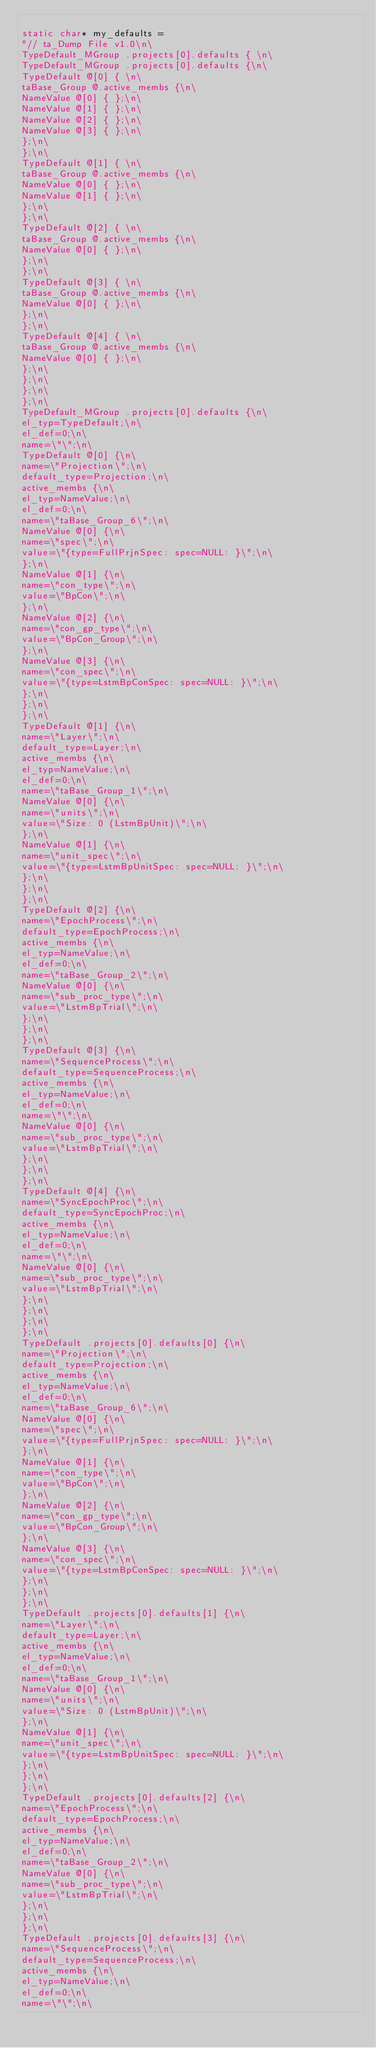<code> <loc_0><loc_0><loc_500><loc_500><_C++_>
static char* my_defaults = 
"// ta_Dump File v1.0\n\
TypeDefault_MGroup .projects[0].defaults { \n\
TypeDefault_MGroup .projects[0].defaults {\n\
TypeDefault @[0] { \n\
taBase_Group @.active_membs {\n\
NameValue @[0] { };\n\
NameValue @[1] { };\n\
NameValue @[2] { };\n\
NameValue @[3] { };\n\
};\n\
};\n\
TypeDefault @[1] { \n\
taBase_Group @.active_membs {\n\
NameValue @[0] { };\n\
NameValue @[1] { };\n\
};\n\
};\n\
TypeDefault @[2] { \n\
taBase_Group @.active_membs {\n\
NameValue @[0] { };\n\
};\n\
};\n\
TypeDefault @[3] { \n\
taBase_Group @.active_membs {\n\
NameValue @[0] { };\n\
};\n\
};\n\
TypeDefault @[4] { \n\
taBase_Group @.active_membs {\n\
NameValue @[0] { };\n\
};\n\
};\n\
};\n\
};\n\
TypeDefault_MGroup .projects[0].defaults {\n\
el_typ=TypeDefault;\n\
el_def=0;\n\
name=\"\";\n\
TypeDefault @[0] {\n\
name=\"Projection\";\n\
default_type=Projection;\n\
active_membs {\n\
el_typ=NameValue;\n\
el_def=0;\n\
name=\"taBase_Group_6\";\n\
NameValue @[0] {\n\
name=\"spec\";\n\
value=\"{type=FullPrjnSpec: spec=NULL: }\";\n\
};\n\
NameValue @[1] {\n\
name=\"con_type\";\n\
value=\"BpCon\";\n\
};\n\
NameValue @[2] {\n\
name=\"con_gp_type\";\n\
value=\"BpCon_Group\";\n\
};\n\
NameValue @[3] {\n\
name=\"con_spec\";\n\
value=\"{type=LstmBpConSpec: spec=NULL: }\";\n\
};\n\
};\n\
};\n\
TypeDefault @[1] {\n\
name=\"Layer\";\n\
default_type=Layer;\n\
active_membs {\n\
el_typ=NameValue;\n\
el_def=0;\n\
name=\"taBase_Group_1\";\n\
NameValue @[0] {\n\
name=\"units\";\n\
value=\"Size: 0 (LstmBpUnit)\";\n\
};\n\
NameValue @[1] {\n\
name=\"unit_spec\";\n\
value=\"{type=LstmBpUnitSpec: spec=NULL: }\";\n\
};\n\
};\n\
};\n\
TypeDefault @[2] {\n\
name=\"EpochProcess\";\n\
default_type=EpochProcess;\n\
active_membs {\n\
el_typ=NameValue;\n\
el_def=0;\n\
name=\"taBase_Group_2\";\n\
NameValue @[0] {\n\
name=\"sub_proc_type\";\n\
value=\"LstmBpTrial\";\n\
};\n\
};\n\
};\n\
TypeDefault @[3] {\n\
name=\"SequenceProcess\";\n\
default_type=SequenceProcess;\n\
active_membs {\n\
el_typ=NameValue;\n\
el_def=0;\n\
name=\"\";\n\
NameValue @[0] {\n\
name=\"sub_proc_type\";\n\
value=\"LstmBpTrial\";\n\
};\n\
};\n\
};\n\
TypeDefault @[4] {\n\
name=\"SyncEpochProc\";\n\
default_type=SyncEpochProc;\n\
active_membs {\n\
el_typ=NameValue;\n\
el_def=0;\n\
name=\"\";\n\
NameValue @[0] {\n\
name=\"sub_proc_type\";\n\
value=\"LstmBpTrial\";\n\
};\n\
};\n\
};\n\
};\n\
TypeDefault .projects[0].defaults[0] {\n\
name=\"Projection\";\n\
default_type=Projection;\n\
active_membs {\n\
el_typ=NameValue;\n\
el_def=0;\n\
name=\"taBase_Group_6\";\n\
NameValue @[0] {\n\
name=\"spec\";\n\
value=\"{type=FullPrjnSpec: spec=NULL: }\";\n\
};\n\
NameValue @[1] {\n\
name=\"con_type\";\n\
value=\"BpCon\";\n\
};\n\
NameValue @[2] {\n\
name=\"con_gp_type\";\n\
value=\"BpCon_Group\";\n\
};\n\
NameValue @[3] {\n\
name=\"con_spec\";\n\
value=\"{type=LstmBpConSpec: spec=NULL: }\";\n\
};\n\
};\n\
};\n\
TypeDefault .projects[0].defaults[1] {\n\
name=\"Layer\";\n\
default_type=Layer;\n\
active_membs {\n\
el_typ=NameValue;\n\
el_def=0;\n\
name=\"taBase_Group_1\";\n\
NameValue @[0] {\n\
name=\"units\";\n\
value=\"Size: 0 (LstmBpUnit)\";\n\
};\n\
NameValue @[1] {\n\
name=\"unit_spec\";\n\
value=\"{type=LstmBpUnitSpec: spec=NULL: }\";\n\
};\n\
};\n\
};\n\
TypeDefault .projects[0].defaults[2] {\n\
name=\"EpochProcess\";\n\
default_type=EpochProcess;\n\
active_membs {\n\
el_typ=NameValue;\n\
el_def=0;\n\
name=\"taBase_Group_2\";\n\
NameValue @[0] {\n\
name=\"sub_proc_type\";\n\
value=\"LstmBpTrial\";\n\
};\n\
};\n\
};\n\
TypeDefault .projects[0].defaults[3] {\n\
name=\"SequenceProcess\";\n\
default_type=SequenceProcess;\n\
active_membs {\n\
el_typ=NameValue;\n\
el_def=0;\n\
name=\"\";\n\</code> 